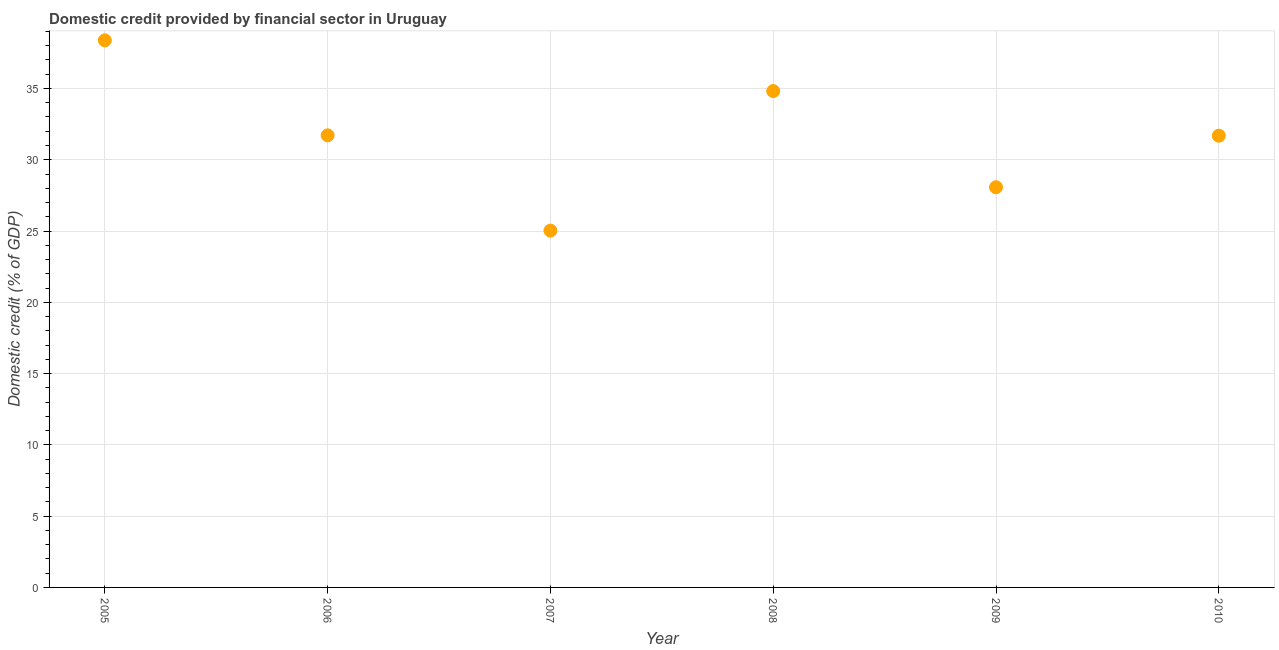What is the domestic credit provided by financial sector in 2007?
Your answer should be very brief. 25.03. Across all years, what is the maximum domestic credit provided by financial sector?
Your answer should be very brief. 38.38. Across all years, what is the minimum domestic credit provided by financial sector?
Offer a very short reply. 25.03. In which year was the domestic credit provided by financial sector minimum?
Ensure brevity in your answer.  2007. What is the sum of the domestic credit provided by financial sector?
Give a very brief answer. 189.7. What is the difference between the domestic credit provided by financial sector in 2006 and 2009?
Offer a very short reply. 3.64. What is the average domestic credit provided by financial sector per year?
Your answer should be very brief. 31.62. What is the median domestic credit provided by financial sector?
Your answer should be very brief. 31.7. Do a majority of the years between 2009 and 2005 (inclusive) have domestic credit provided by financial sector greater than 26 %?
Keep it short and to the point. Yes. What is the ratio of the domestic credit provided by financial sector in 2008 to that in 2009?
Your response must be concise. 1.24. Is the difference between the domestic credit provided by financial sector in 2007 and 2009 greater than the difference between any two years?
Provide a short and direct response. No. What is the difference between the highest and the second highest domestic credit provided by financial sector?
Your answer should be compact. 3.56. What is the difference between the highest and the lowest domestic credit provided by financial sector?
Provide a succinct answer. 13.35. In how many years, is the domestic credit provided by financial sector greater than the average domestic credit provided by financial sector taken over all years?
Keep it short and to the point. 4. Does the domestic credit provided by financial sector monotonically increase over the years?
Your answer should be very brief. No. What is the difference between two consecutive major ticks on the Y-axis?
Offer a terse response. 5. Are the values on the major ticks of Y-axis written in scientific E-notation?
Provide a short and direct response. No. Does the graph contain grids?
Give a very brief answer. Yes. What is the title of the graph?
Provide a succinct answer. Domestic credit provided by financial sector in Uruguay. What is the label or title of the X-axis?
Your answer should be very brief. Year. What is the label or title of the Y-axis?
Provide a short and direct response. Domestic credit (% of GDP). What is the Domestic credit (% of GDP) in 2005?
Give a very brief answer. 38.38. What is the Domestic credit (% of GDP) in 2006?
Your response must be concise. 31.71. What is the Domestic credit (% of GDP) in 2007?
Your response must be concise. 25.03. What is the Domestic credit (% of GDP) in 2008?
Make the answer very short. 34.82. What is the Domestic credit (% of GDP) in 2009?
Your response must be concise. 28.07. What is the Domestic credit (% of GDP) in 2010?
Keep it short and to the point. 31.69. What is the difference between the Domestic credit (% of GDP) in 2005 and 2006?
Your answer should be very brief. 6.66. What is the difference between the Domestic credit (% of GDP) in 2005 and 2007?
Keep it short and to the point. 13.35. What is the difference between the Domestic credit (% of GDP) in 2005 and 2008?
Give a very brief answer. 3.56. What is the difference between the Domestic credit (% of GDP) in 2005 and 2009?
Make the answer very short. 10.3. What is the difference between the Domestic credit (% of GDP) in 2005 and 2010?
Offer a terse response. 6.69. What is the difference between the Domestic credit (% of GDP) in 2006 and 2007?
Provide a short and direct response. 6.69. What is the difference between the Domestic credit (% of GDP) in 2006 and 2008?
Provide a short and direct response. -3.1. What is the difference between the Domestic credit (% of GDP) in 2006 and 2009?
Give a very brief answer. 3.64. What is the difference between the Domestic credit (% of GDP) in 2006 and 2010?
Offer a very short reply. 0.03. What is the difference between the Domestic credit (% of GDP) in 2007 and 2008?
Make the answer very short. -9.79. What is the difference between the Domestic credit (% of GDP) in 2007 and 2009?
Give a very brief answer. -3.04. What is the difference between the Domestic credit (% of GDP) in 2007 and 2010?
Provide a succinct answer. -6.66. What is the difference between the Domestic credit (% of GDP) in 2008 and 2009?
Provide a succinct answer. 6.75. What is the difference between the Domestic credit (% of GDP) in 2008 and 2010?
Give a very brief answer. 3.13. What is the difference between the Domestic credit (% of GDP) in 2009 and 2010?
Offer a terse response. -3.62. What is the ratio of the Domestic credit (% of GDP) in 2005 to that in 2006?
Keep it short and to the point. 1.21. What is the ratio of the Domestic credit (% of GDP) in 2005 to that in 2007?
Make the answer very short. 1.53. What is the ratio of the Domestic credit (% of GDP) in 2005 to that in 2008?
Your answer should be very brief. 1.1. What is the ratio of the Domestic credit (% of GDP) in 2005 to that in 2009?
Make the answer very short. 1.37. What is the ratio of the Domestic credit (% of GDP) in 2005 to that in 2010?
Make the answer very short. 1.21. What is the ratio of the Domestic credit (% of GDP) in 2006 to that in 2007?
Keep it short and to the point. 1.27. What is the ratio of the Domestic credit (% of GDP) in 2006 to that in 2008?
Provide a short and direct response. 0.91. What is the ratio of the Domestic credit (% of GDP) in 2006 to that in 2009?
Your response must be concise. 1.13. What is the ratio of the Domestic credit (% of GDP) in 2007 to that in 2008?
Your answer should be very brief. 0.72. What is the ratio of the Domestic credit (% of GDP) in 2007 to that in 2009?
Your answer should be compact. 0.89. What is the ratio of the Domestic credit (% of GDP) in 2007 to that in 2010?
Keep it short and to the point. 0.79. What is the ratio of the Domestic credit (% of GDP) in 2008 to that in 2009?
Offer a terse response. 1.24. What is the ratio of the Domestic credit (% of GDP) in 2008 to that in 2010?
Give a very brief answer. 1.1. What is the ratio of the Domestic credit (% of GDP) in 2009 to that in 2010?
Ensure brevity in your answer.  0.89. 